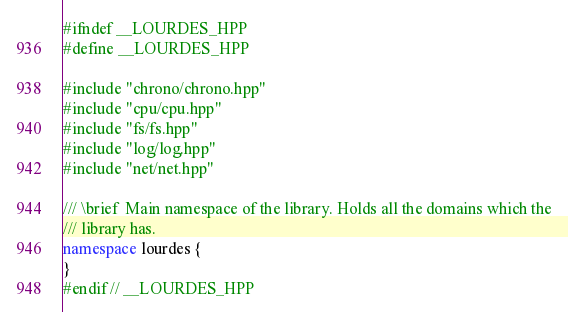<code> <loc_0><loc_0><loc_500><loc_500><_C++_>#ifndef __LOURDES_HPP
#define __LOURDES_HPP

#include "chrono/chrono.hpp"
#include "cpu/cpu.hpp"
#include "fs/fs.hpp"
#include "log/log.hpp"
#include "net/net.hpp"

/// \brief  Main namespace of the library. Holds all the domains which the
/// library has.
namespace lourdes {
}
#endif // __LOURDES_HPP
</code> 